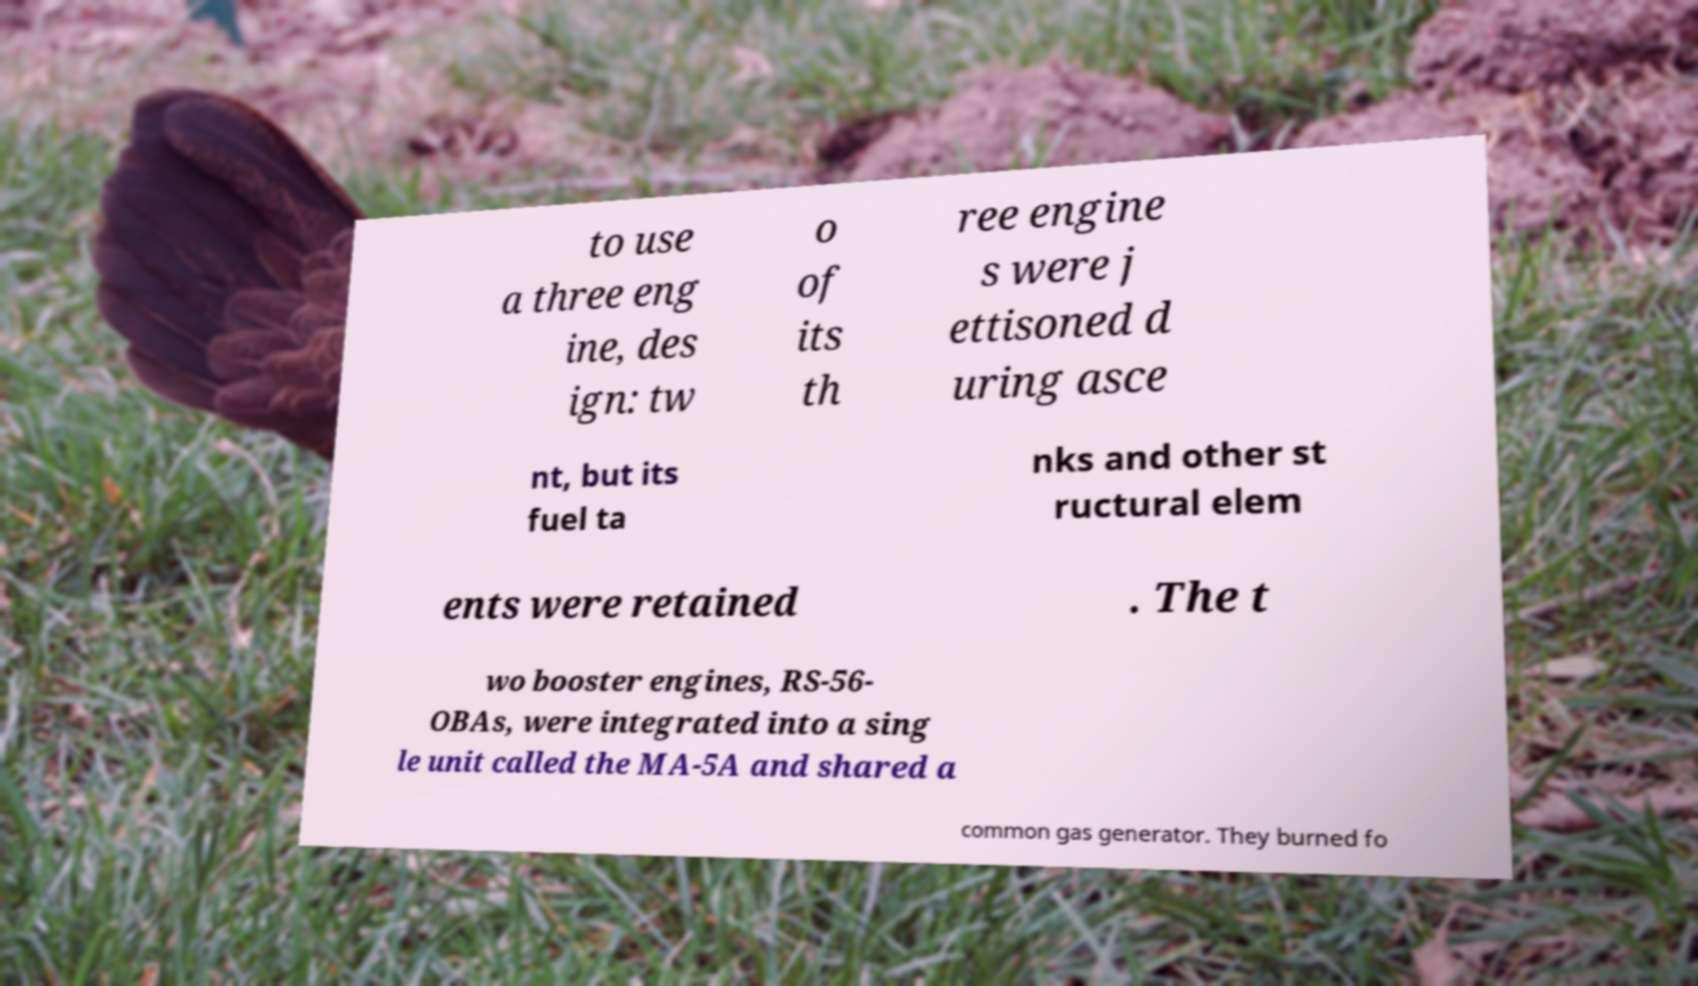Can you accurately transcribe the text from the provided image for me? to use a three eng ine, des ign: tw o of its th ree engine s were j ettisoned d uring asce nt, but its fuel ta nks and other st ructural elem ents were retained . The t wo booster engines, RS-56- OBAs, were integrated into a sing le unit called the MA-5A and shared a common gas generator. They burned fo 